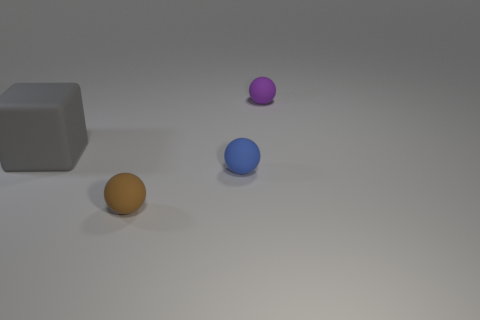Add 1 tiny brown matte blocks. How many objects exist? 5 Add 3 large gray cubes. How many large gray cubes are left? 4 Add 1 red metallic things. How many red metallic things exist? 1 Subtract all blue balls. How many balls are left? 2 Subtract 0 gray spheres. How many objects are left? 4 Subtract all cubes. How many objects are left? 3 Subtract 1 cubes. How many cubes are left? 0 Subtract all red balls. Subtract all purple cylinders. How many balls are left? 3 Subtract all green cylinders. How many red balls are left? 0 Subtract all small brown balls. Subtract all spheres. How many objects are left? 0 